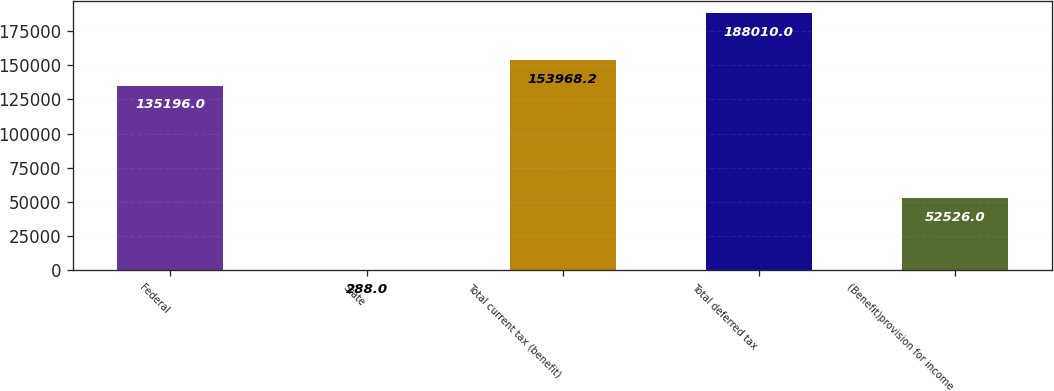Convert chart. <chart><loc_0><loc_0><loc_500><loc_500><bar_chart><fcel>Federal<fcel>State<fcel>Total current tax (benefit)<fcel>Total deferred tax<fcel>(Benefit)provision for income<nl><fcel>135196<fcel>288<fcel>153968<fcel>188010<fcel>52526<nl></chart> 